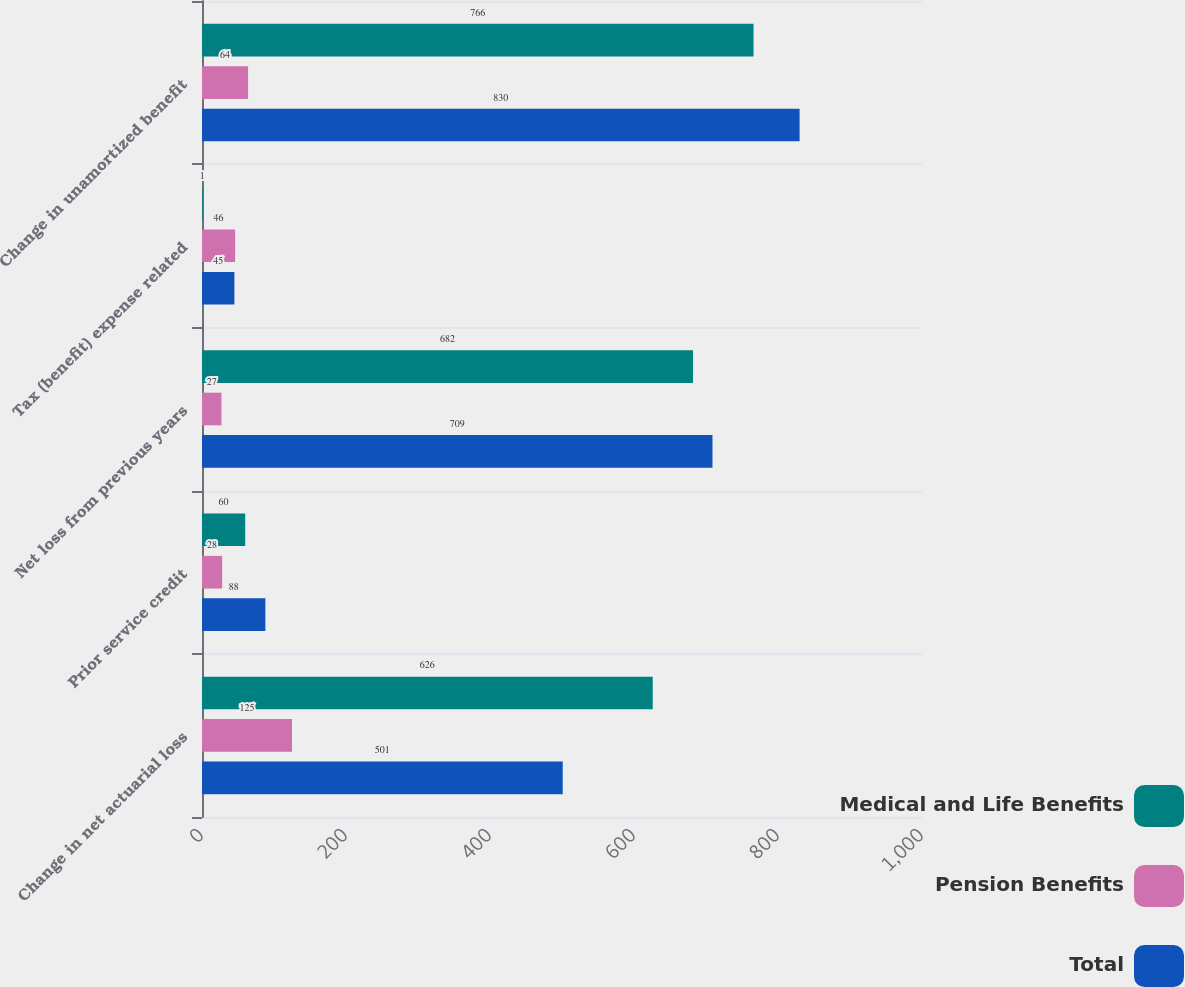Convert chart to OTSL. <chart><loc_0><loc_0><loc_500><loc_500><stacked_bar_chart><ecel><fcel>Change in net actuarial loss<fcel>Prior service credit<fcel>Net loss from previous years<fcel>Tax (benefit) expense related<fcel>Change in unamortized benefit<nl><fcel>Medical and Life Benefits<fcel>626<fcel>60<fcel>682<fcel>1<fcel>766<nl><fcel>Pension Benefits<fcel>125<fcel>28<fcel>27<fcel>46<fcel>64<nl><fcel>Total<fcel>501<fcel>88<fcel>709<fcel>45<fcel>830<nl></chart> 